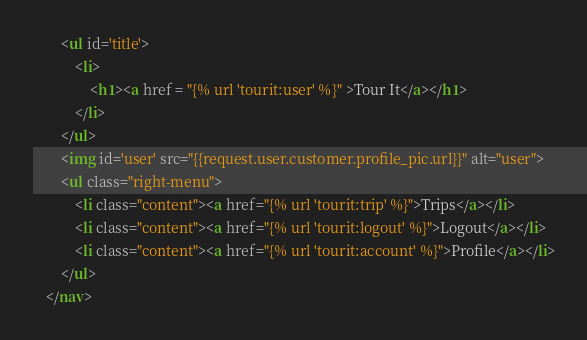Convert code to text. <code><loc_0><loc_0><loc_500><loc_500><_HTML_>        <ul id='title'>
            <li>
                <h1><a href = "{% url 'tourit:user' %}" >Tour It</a></h1>
            </li>
        </ul>
        <img id='user' src="{{request.user.customer.profile_pic.url}}" alt="user">
        <ul class="right-menu">
            <li class="content"><a href="{% url 'tourit:trip' %}">Trips</a></li>
            <li class="content"><a href="{% url 'tourit:logout' %}">Logout</a></li>
            <li class="content"><a href="{% url 'tourit:account' %}">Profile</a></li>
        </ul>
    </nav>
</code> 